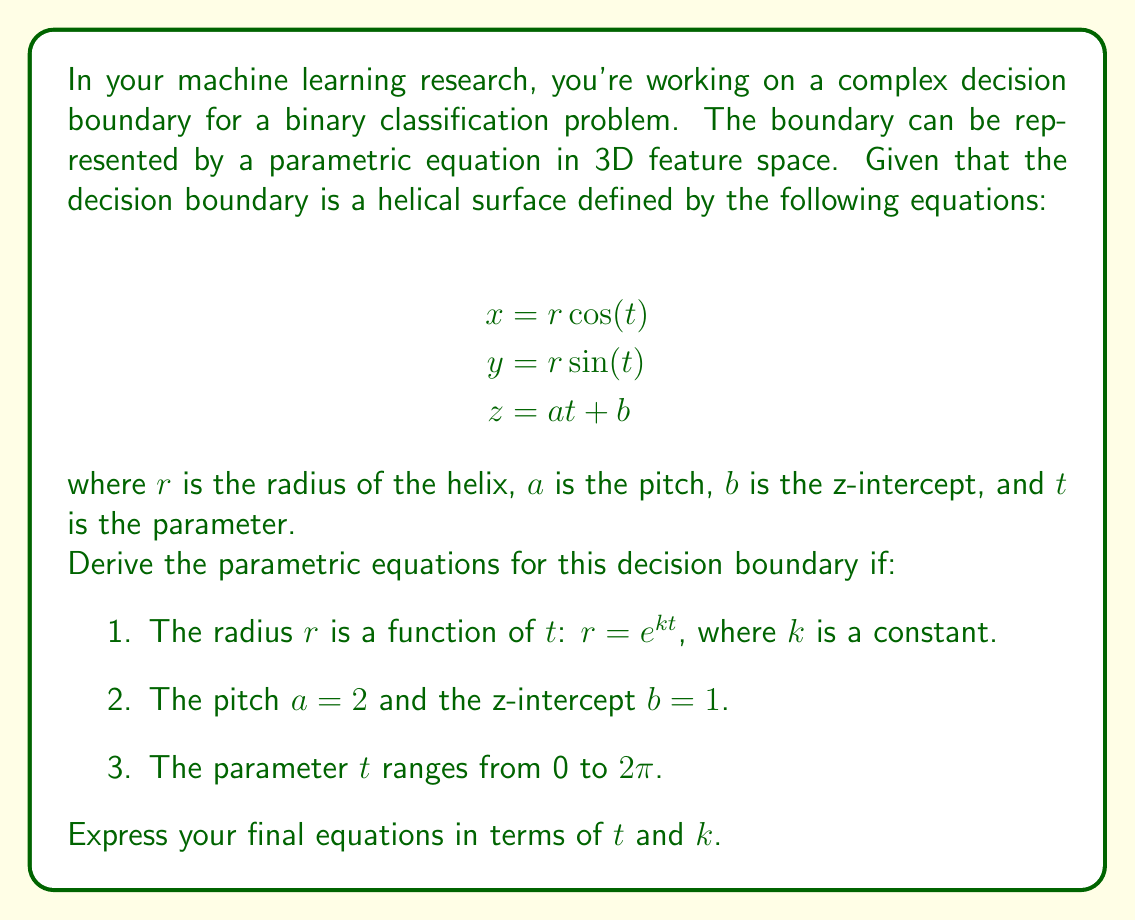Solve this math problem. To derive the parametric equations for this complex machine learning decision boundary, we'll follow these steps:

1. Start with the given helical surface equations:
   $$x = r \cos(t)$$
   $$y = r \sin(t)$$
   $$z = at + b$$

2. Substitute the given information:
   - $r = e^{kt}$
   - $a = 2$
   - $b = 1$

3. Rewrite the equations with these substitutions:
   $$x = e^{kt} \cos(t)$$
   $$y = e^{kt} \sin(t)$$
   $$z = 2t + 1$$

4. The parameter $t$ ranges from 0 to $2\pi$, so we don't need to modify the domain of $t$.

5. Our final parametric equations for the decision boundary are:
   $$x = e^{kt} \cos(t)$$
   $$y = e^{kt} \sin(t)$$
   $$z = 2t + 1$$
   where $0 \leq t \leq 2\pi$

These equations describe a helical surface that expands exponentially as it rises, creating a complex decision boundary in 3D feature space. The constant $k$ controls the rate of expansion: a positive $k$ results in an expanding helix, while a negative $k$ would create a contracting helix.
Answer: The parametric equations for the complex machine learning decision boundary are:

$$x = e^{kt} \cos(t)$$
$$y = e^{kt} \sin(t)$$
$$z = 2t + 1$$

where $0 \leq t \leq 2\pi$ and $k$ is a constant controlling the rate of radial expansion. 